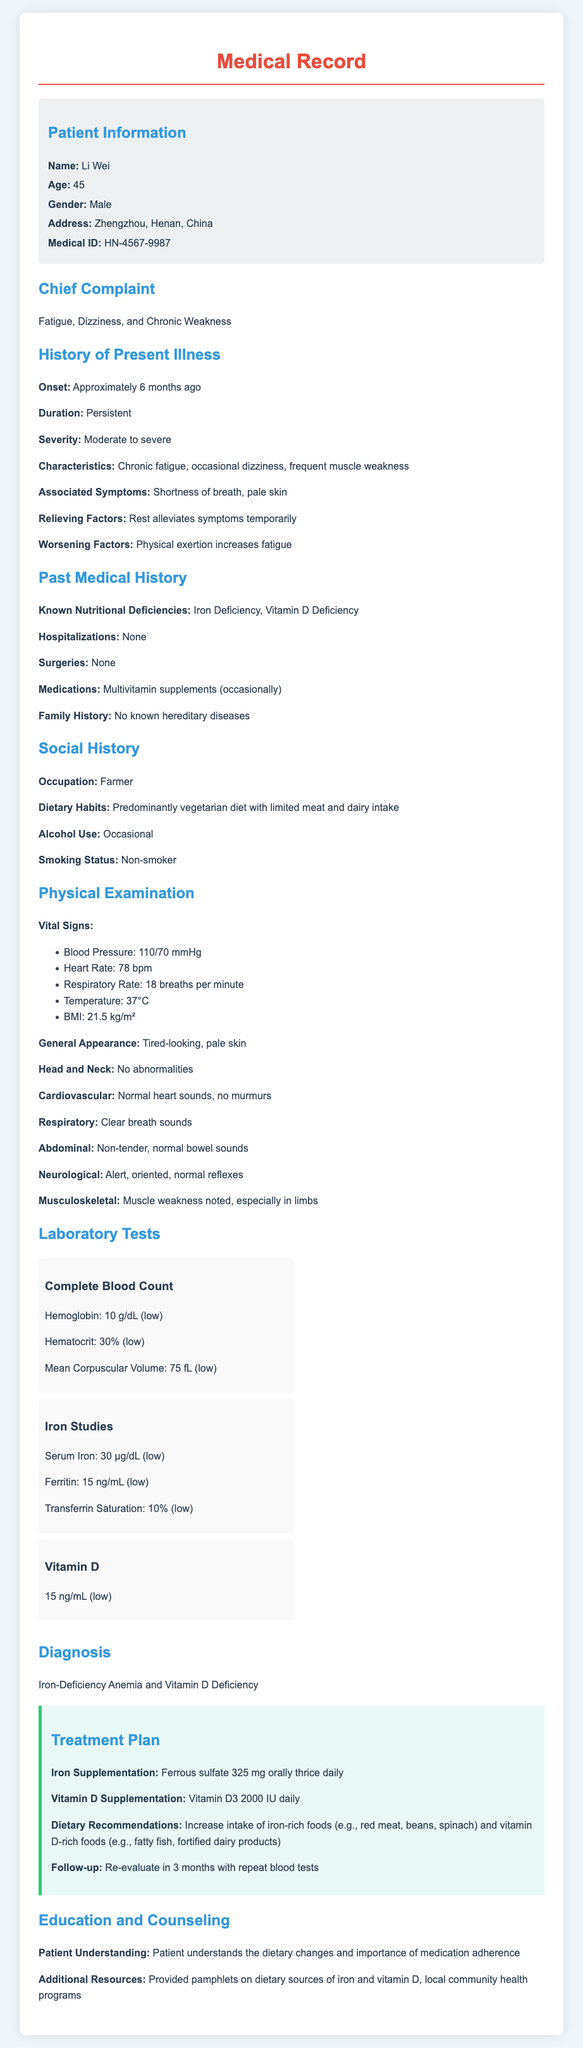what is the patient's name? The patient's name is stated in the document under Patient Information section.
Answer: Li Wei what is the age of the patient? The age of the patient is mentioned in the Patient Information section.
Answer: 45 what are the known nutritional deficiencies? The known nutritional deficiencies are listed in the Past Medical History section.
Answer: Iron Deficiency, Vitamin D Deficiency what is the treatment for Vitamin D Deficiency? The treatment for Vitamin D Deficiency can be found in the Treatment Plan section.
Answer: Vitamin D3 2000 IU daily what is the blood pressure reading? The blood pressure reading is provided in the Physical Examination section.
Answer: 110/70 mmHg what lifestyle factor may contribute to the patient's condition? The patient's dietary habits are mentioned in the Social History section.
Answer: Predominantly vegetarian diet how long has the patient been experiencing symptoms? The duration of symptoms is detailed in the History of Present Illness section.
Answer: Approximately 6 months ago what is the follow-up plan for the patient? The follow-up plan is found in the Treatment Plan section.
Answer: Re-evaluate in 3 months with repeat blood tests what is the diagnosis given to the patient? The diagnosis is stated in the Diagnosis section of the document.
Answer: Iron-Deficiency Anemia and Vitamin D Deficiency 